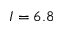<formula> <loc_0><loc_0><loc_500><loc_500>I = 6 . 8</formula> 